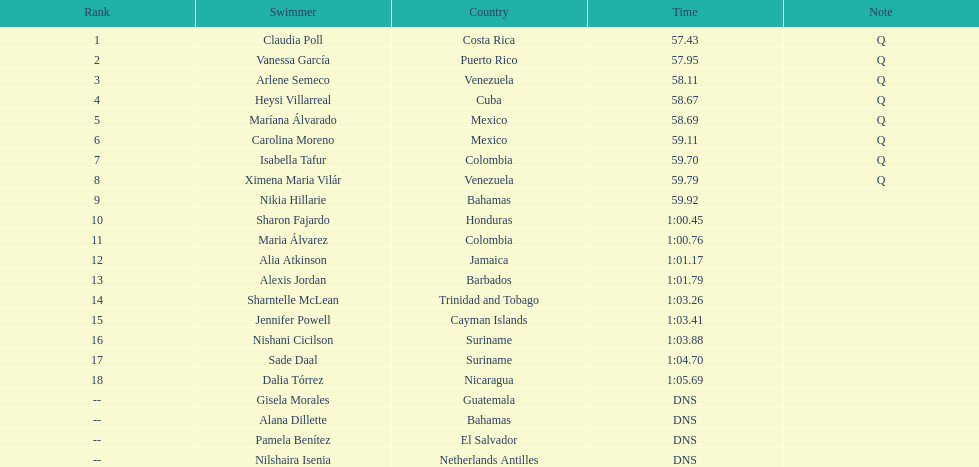What is the number of swimmers originating from mexico? 2. 